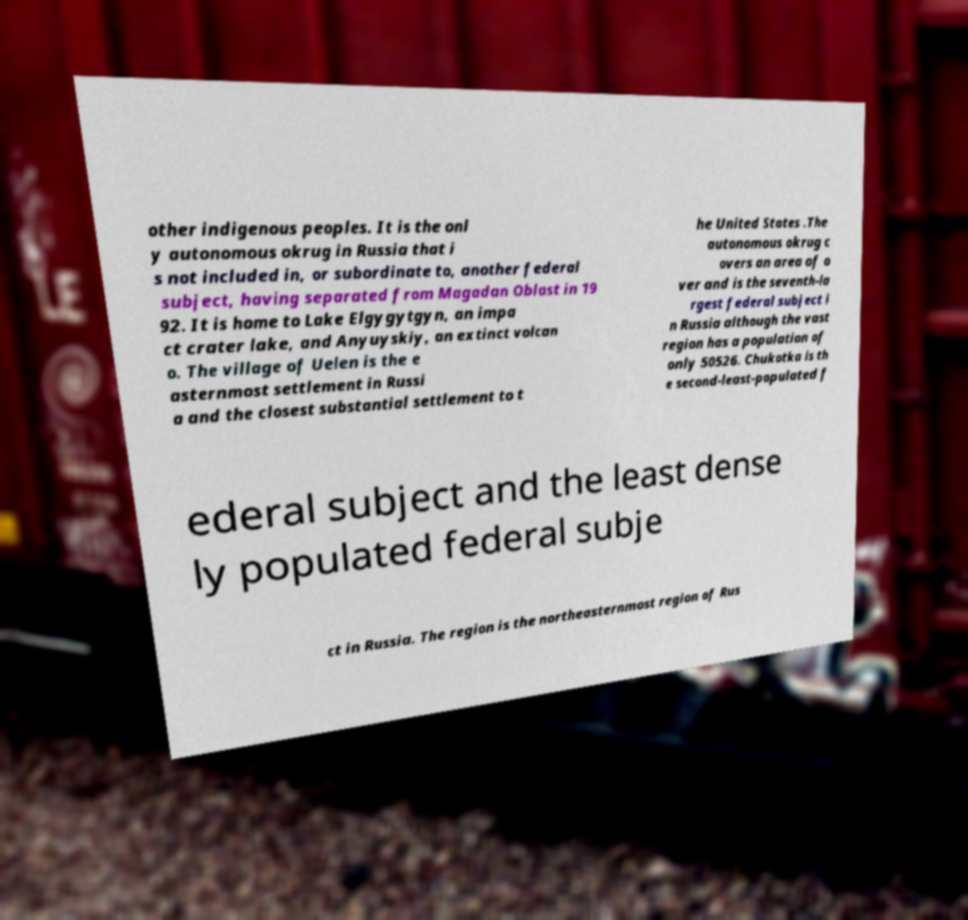Please identify and transcribe the text found in this image. other indigenous peoples. It is the onl y autonomous okrug in Russia that i s not included in, or subordinate to, another federal subject, having separated from Magadan Oblast in 19 92. It is home to Lake Elgygytgyn, an impa ct crater lake, and Anyuyskiy, an extinct volcan o. The village of Uelen is the e asternmost settlement in Russi a and the closest substantial settlement to t he United States .The autonomous okrug c overs an area of o ver and is the seventh-la rgest federal subject i n Russia although the vast region has a population of only 50526. Chukotka is th e second-least-populated f ederal subject and the least dense ly populated federal subje ct in Russia. The region is the northeasternmost region of Rus 